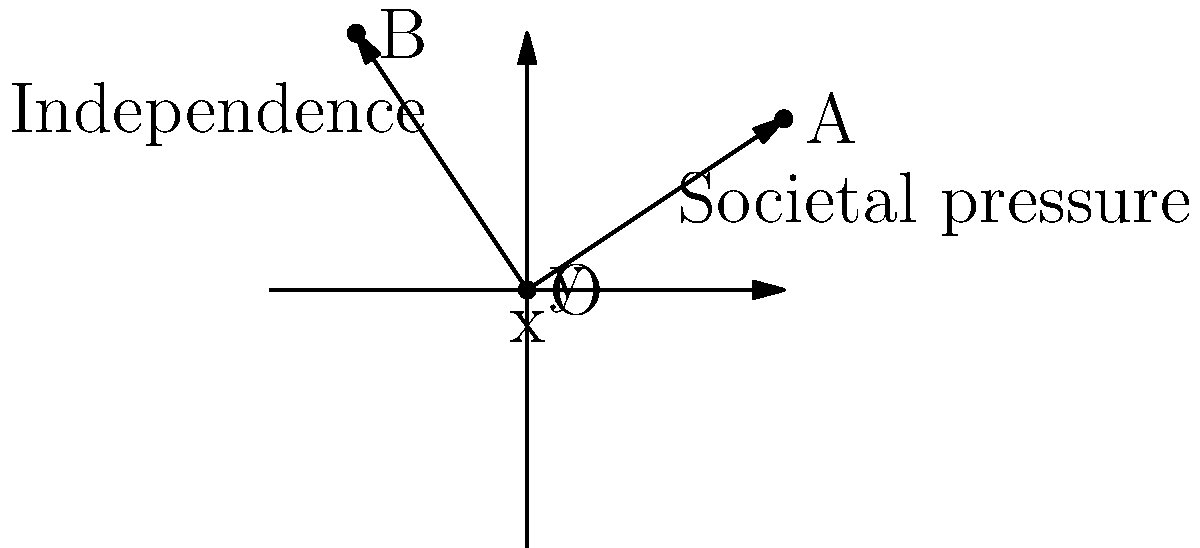In the given coordinate system, vector $\vec{OA}$ represents societal pressure, while vector $\vec{OB}$ represents your path to independence. Find a unit vector perpendicular to $\vec{OA}$ that symbolizes your ability to maintain individuality while navigating societal norms. Express your answer in component form. Let's approach this step-by-step:

1) First, we need to find the components of vector $\vec{OA}$:
   $\vec{OA} = (3, 2)$

2) To find a perpendicular vector, we can swap the components and negate one of them:
   Perpendicular vector = $(-2, 3)$ or $(2, -3)$

3) Let's choose $(-2, 3)$ as it points in the direction of independence (vector $\vec{OB}$).

4) Now, we need to normalize this vector to get a unit vector. To do this, we divide by its magnitude:

   Magnitude = $\sqrt{(-2)^2 + 3^2} = \sqrt{4 + 9} = \sqrt{13}$

5) The unit vector is:
   $\frac{1}{\sqrt{13}}(-2, 3) = (-\frac{2}{\sqrt{13}}, \frac{3}{\sqrt{13}})$

This unit vector represents your ability to maintain individuality (perpendicular to societal pressure) while still existing within the same space (coordinate system) as societal norms.
Answer: $(-\frac{2}{\sqrt{13}}, \frac{3}{\sqrt{13}})$ 